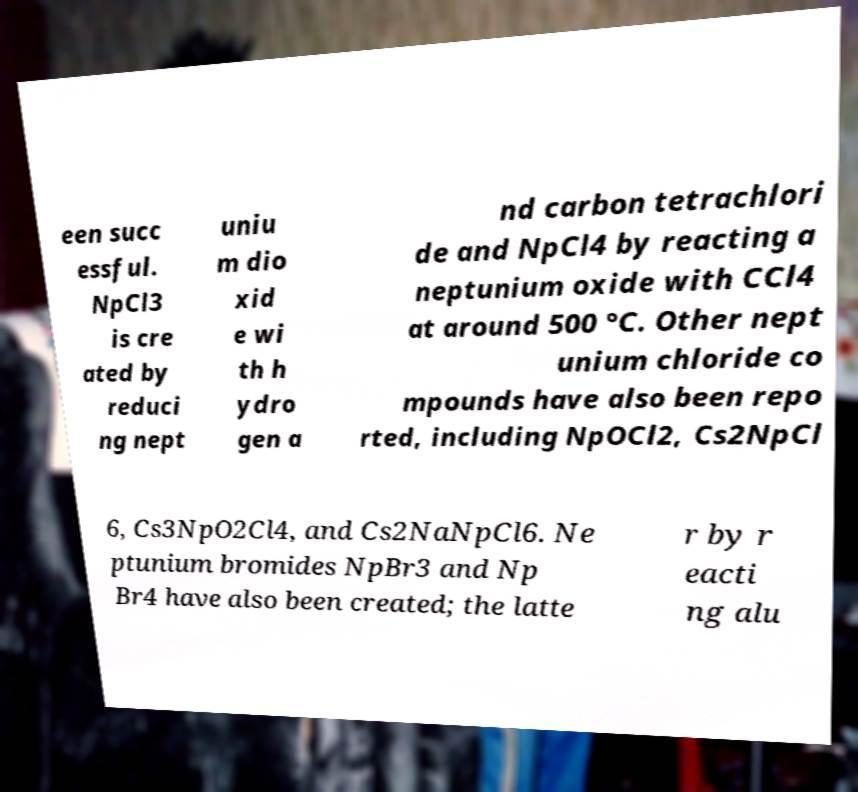There's text embedded in this image that I need extracted. Can you transcribe it verbatim? een succ essful. NpCl3 is cre ated by reduci ng nept uniu m dio xid e wi th h ydro gen a nd carbon tetrachlori de and NpCl4 by reacting a neptunium oxide with CCl4 at around 500 °C. Other nept unium chloride co mpounds have also been repo rted, including NpOCl2, Cs2NpCl 6, Cs3NpO2Cl4, and Cs2NaNpCl6. Ne ptunium bromides NpBr3 and Np Br4 have also been created; the latte r by r eacti ng alu 